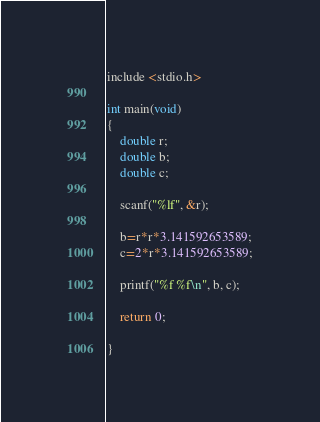Convert code to text. <code><loc_0><loc_0><loc_500><loc_500><_C_>include <stdio.h>

int main(void)
{
	double r;
	double b;
	double c;

	scanf("%lf", &r);

	b=r*r*3.141592653589;
	c=2*r*3.141592653589;

	printf("%f %f\n", b, c);

	return 0;

}</code> 